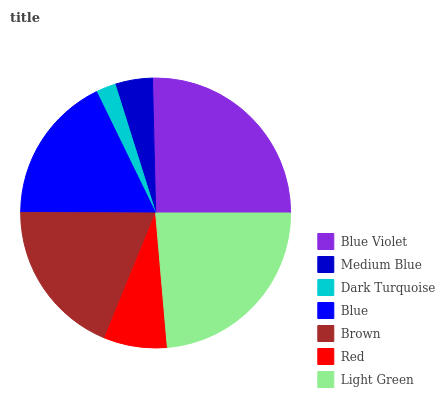Is Dark Turquoise the minimum?
Answer yes or no. Yes. Is Blue Violet the maximum?
Answer yes or no. Yes. Is Medium Blue the minimum?
Answer yes or no. No. Is Medium Blue the maximum?
Answer yes or no. No. Is Blue Violet greater than Medium Blue?
Answer yes or no. Yes. Is Medium Blue less than Blue Violet?
Answer yes or no. Yes. Is Medium Blue greater than Blue Violet?
Answer yes or no. No. Is Blue Violet less than Medium Blue?
Answer yes or no. No. Is Blue the high median?
Answer yes or no. Yes. Is Blue the low median?
Answer yes or no. Yes. Is Red the high median?
Answer yes or no. No. Is Blue Violet the low median?
Answer yes or no. No. 